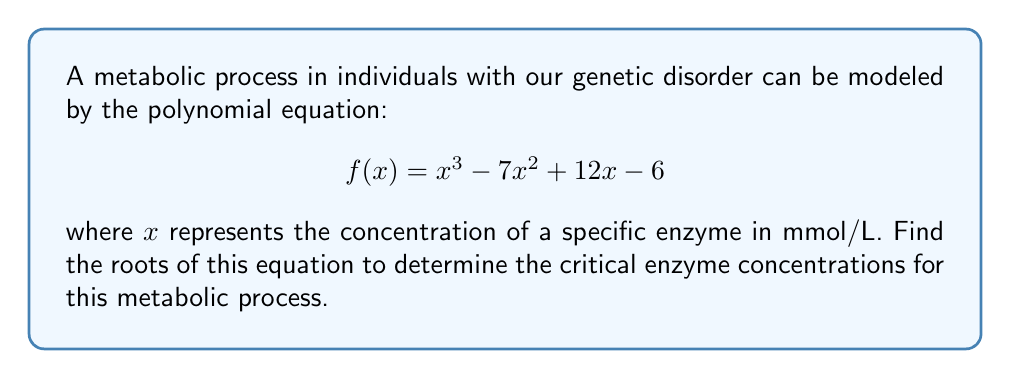Give your solution to this math problem. To find the roots of this polynomial equation, we need to factor it. Let's follow these steps:

1) First, let's check if there are any rational roots using the rational root theorem. The possible rational roots are the factors of the constant term: ±1, ±2, ±3, ±6.

2) Testing these values, we find that $f(1) = 0$. So $(x-1)$ is a factor.

3) We can use polynomial long division to divide $f(x)$ by $(x-1)$:

   $$\frac{x^3 - 7x^2 + 12x - 6}{x-1} = x^2 - 6x + 6$$

4) Now our equation becomes:

   $$(x-1)(x^2 - 6x + 6) = 0$$

5) We need to factor the quadratic term $x^2 - 6x + 6$. Its discriminant is:

   $$b^2 - 4ac = (-6)^2 - 4(1)(6) = 36 - 24 = 12$$

6) This gives us the other two roots:

   $$x = \frac{6 \pm \sqrt{12}}{2} = 3 \pm \sqrt{3}$$

7) Therefore, the fully factored form is:

   $$(x-1)(x-(3+\sqrt{3}))(x-(3-\sqrt{3})) = 0$$

8) The roots are the values that make each factor equal to zero.
Answer: $x = 1$, $x = 3+\sqrt{3}$, $x = 3-\sqrt{3}$ 